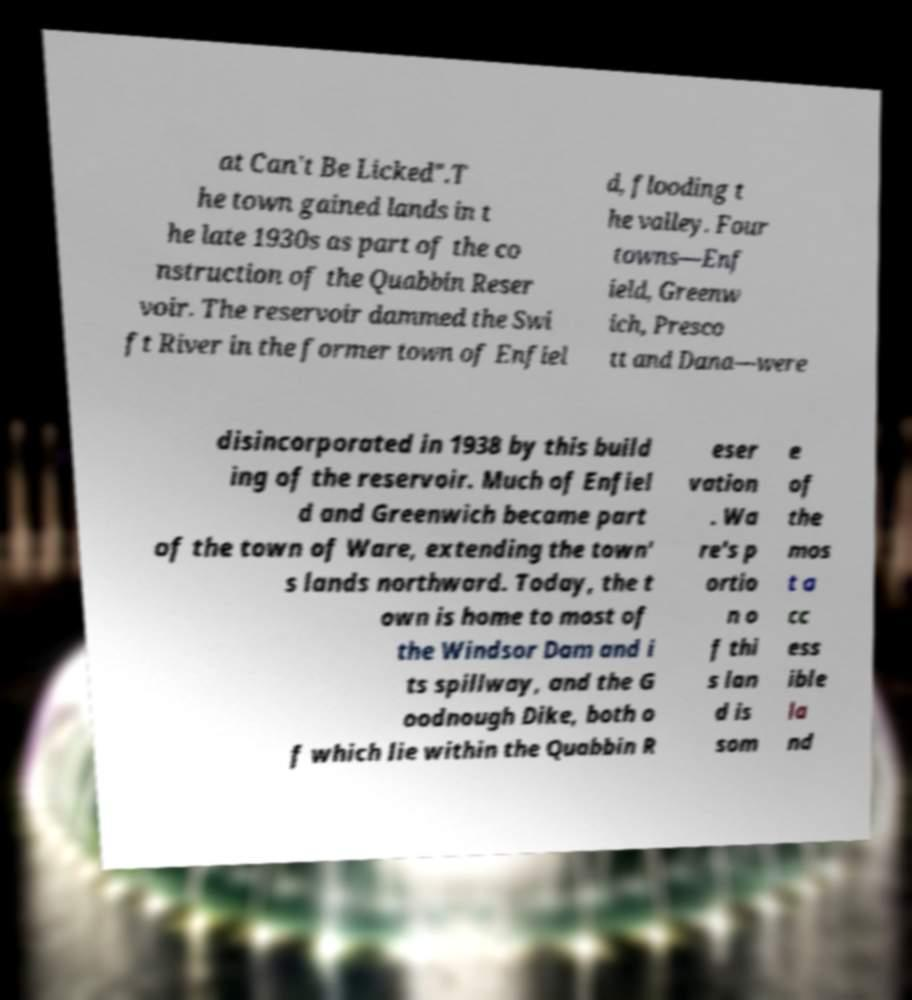Can you accurately transcribe the text from the provided image for me? at Can't Be Licked".T he town gained lands in t he late 1930s as part of the co nstruction of the Quabbin Reser voir. The reservoir dammed the Swi ft River in the former town of Enfiel d, flooding t he valley. Four towns—Enf ield, Greenw ich, Presco tt and Dana—were disincorporated in 1938 by this build ing of the reservoir. Much of Enfiel d and Greenwich became part of the town of Ware, extending the town' s lands northward. Today, the t own is home to most of the Windsor Dam and i ts spillway, and the G oodnough Dike, both o f which lie within the Quabbin R eser vation . Wa re's p ortio n o f thi s lan d is som e of the mos t a cc ess ible la nd 